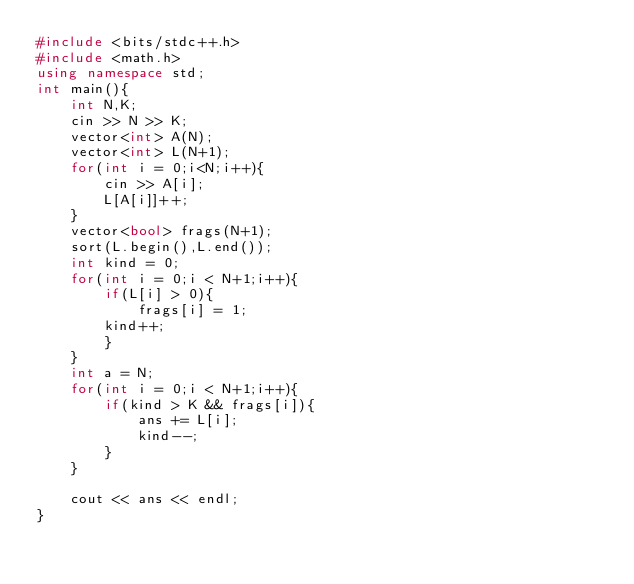Convert code to text. <code><loc_0><loc_0><loc_500><loc_500><_C++_>#include <bits/stdc++.h>
#include <math.h>
using namespace std;
int main(){
    int N,K;
    cin >> N >> K;
    vector<int> A(N);
    vector<int> L(N+1);
    for(int i = 0;i<N;i++){
        cin >> A[i];
        L[A[i]]++;
    }
    vector<bool> frags(N+1);
    sort(L.begin(),L.end());
    int kind = 0;
    for(int i = 0;i < N+1;i++){
        if(L[i] > 0){
            frags[i] = 1;
        kind++;
        }
    }
    int a = N;
    for(int i = 0;i < N+1;i++){
        if(kind > K && frags[i]){
            ans += L[i];
            kind--;
        }
    }

    cout << ans << endl;
}</code> 